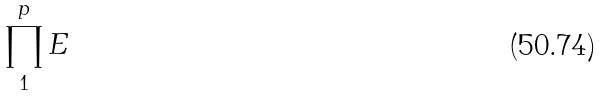Convert formula to latex. <formula><loc_0><loc_0><loc_500><loc_500>\prod _ { 1 } ^ { p } E</formula> 